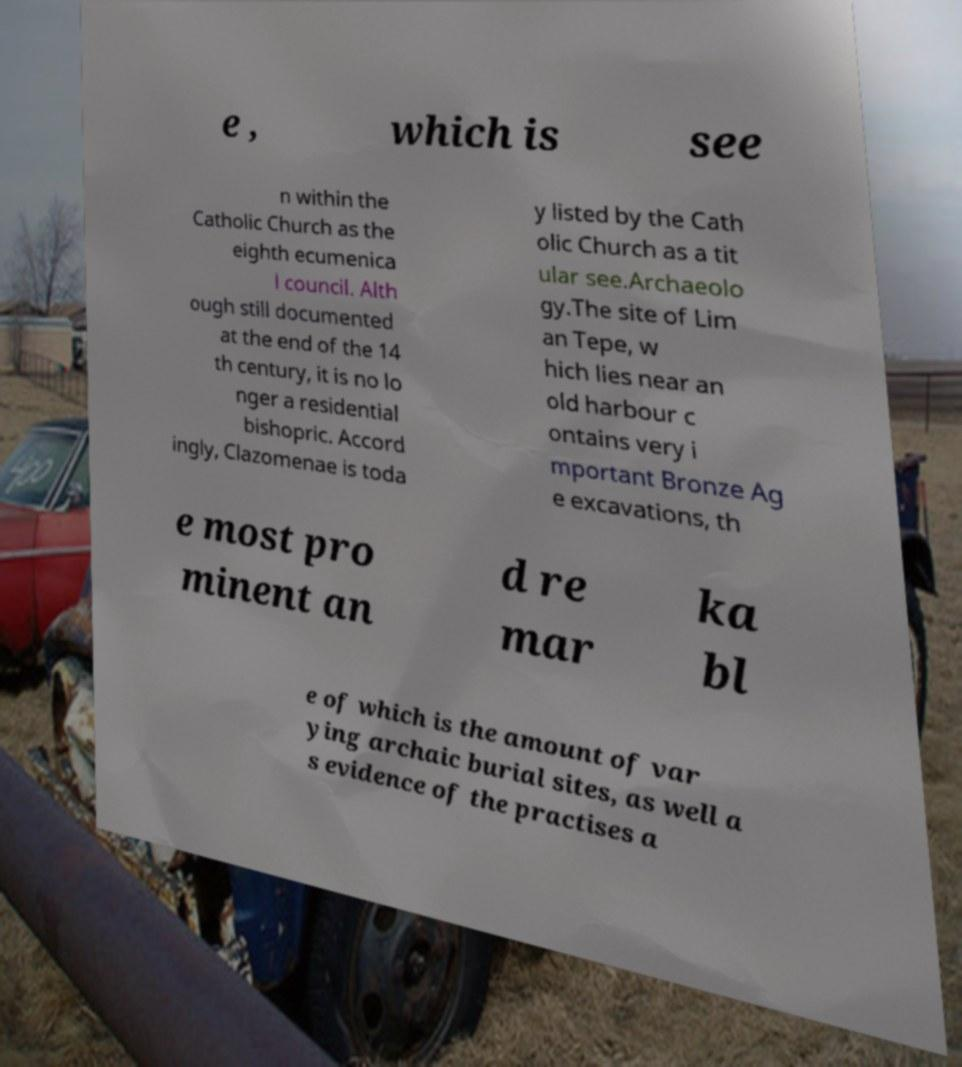Could you assist in decoding the text presented in this image and type it out clearly? e , which is see n within the Catholic Church as the eighth ecumenica l council. Alth ough still documented at the end of the 14 th century, it is no lo nger a residential bishopric. Accord ingly, Clazomenae is toda y listed by the Cath olic Church as a tit ular see.Archaeolo gy.The site of Lim an Tepe, w hich lies near an old harbour c ontains very i mportant Bronze Ag e excavations, th e most pro minent an d re mar ka bl e of which is the amount of var ying archaic burial sites, as well a s evidence of the practises a 